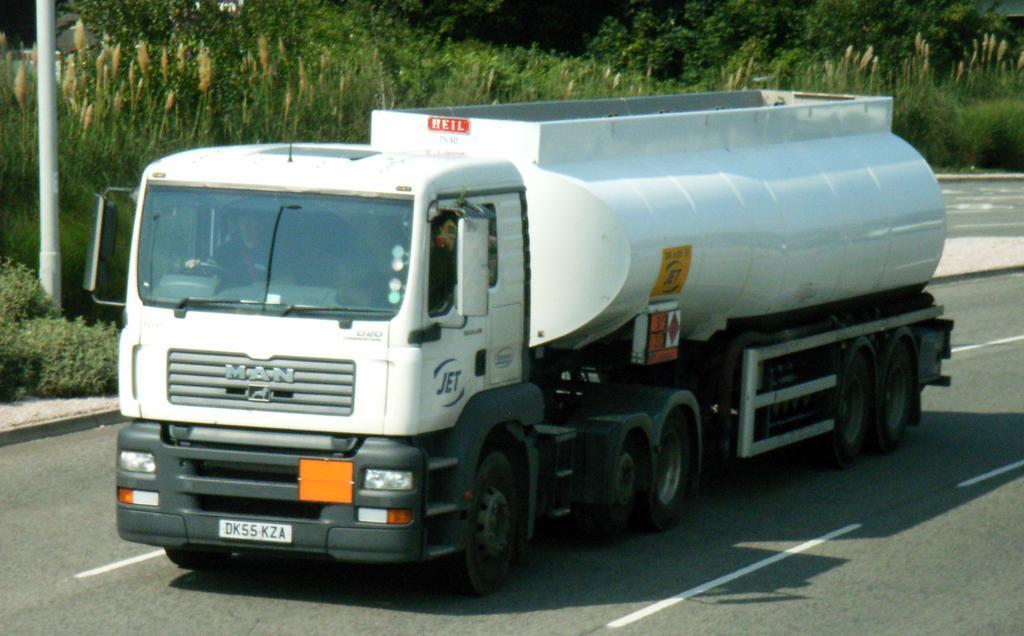How would you summarize this image in a sentence or two? We can see vehicle on the road. In the background we can see trees,plants and pole. 